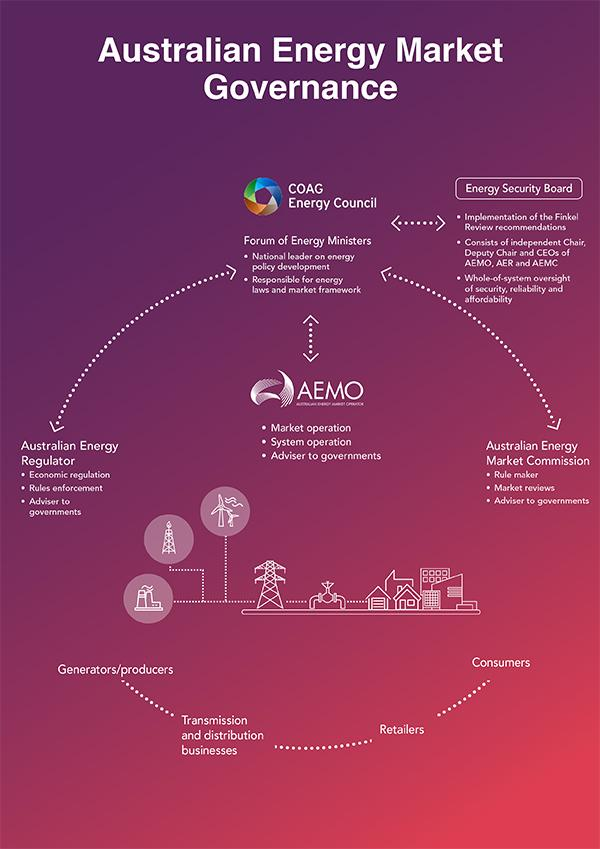Draw attention to some important aspects in this diagram. The Forum of Energy Ministers is responsible for energy laws and the market framework. The Australian Energy Market Commission serves as the authority responsible for making rules in accordance with the flowchart. The Australian Energy Regulator serves as an advisory body to governments. The Energy Security Board is comprised of three points. 